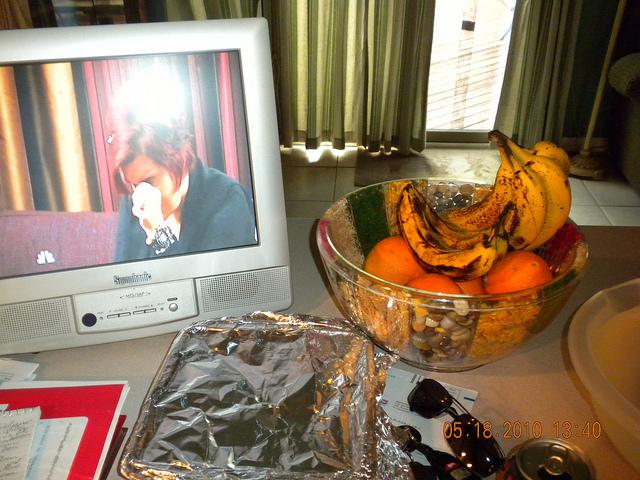Is this picture from this year?
Give a very brief answer. No. Is the fruit edible?
Give a very brief answer. Yes. Is the television on?
Give a very brief answer. Yes. 